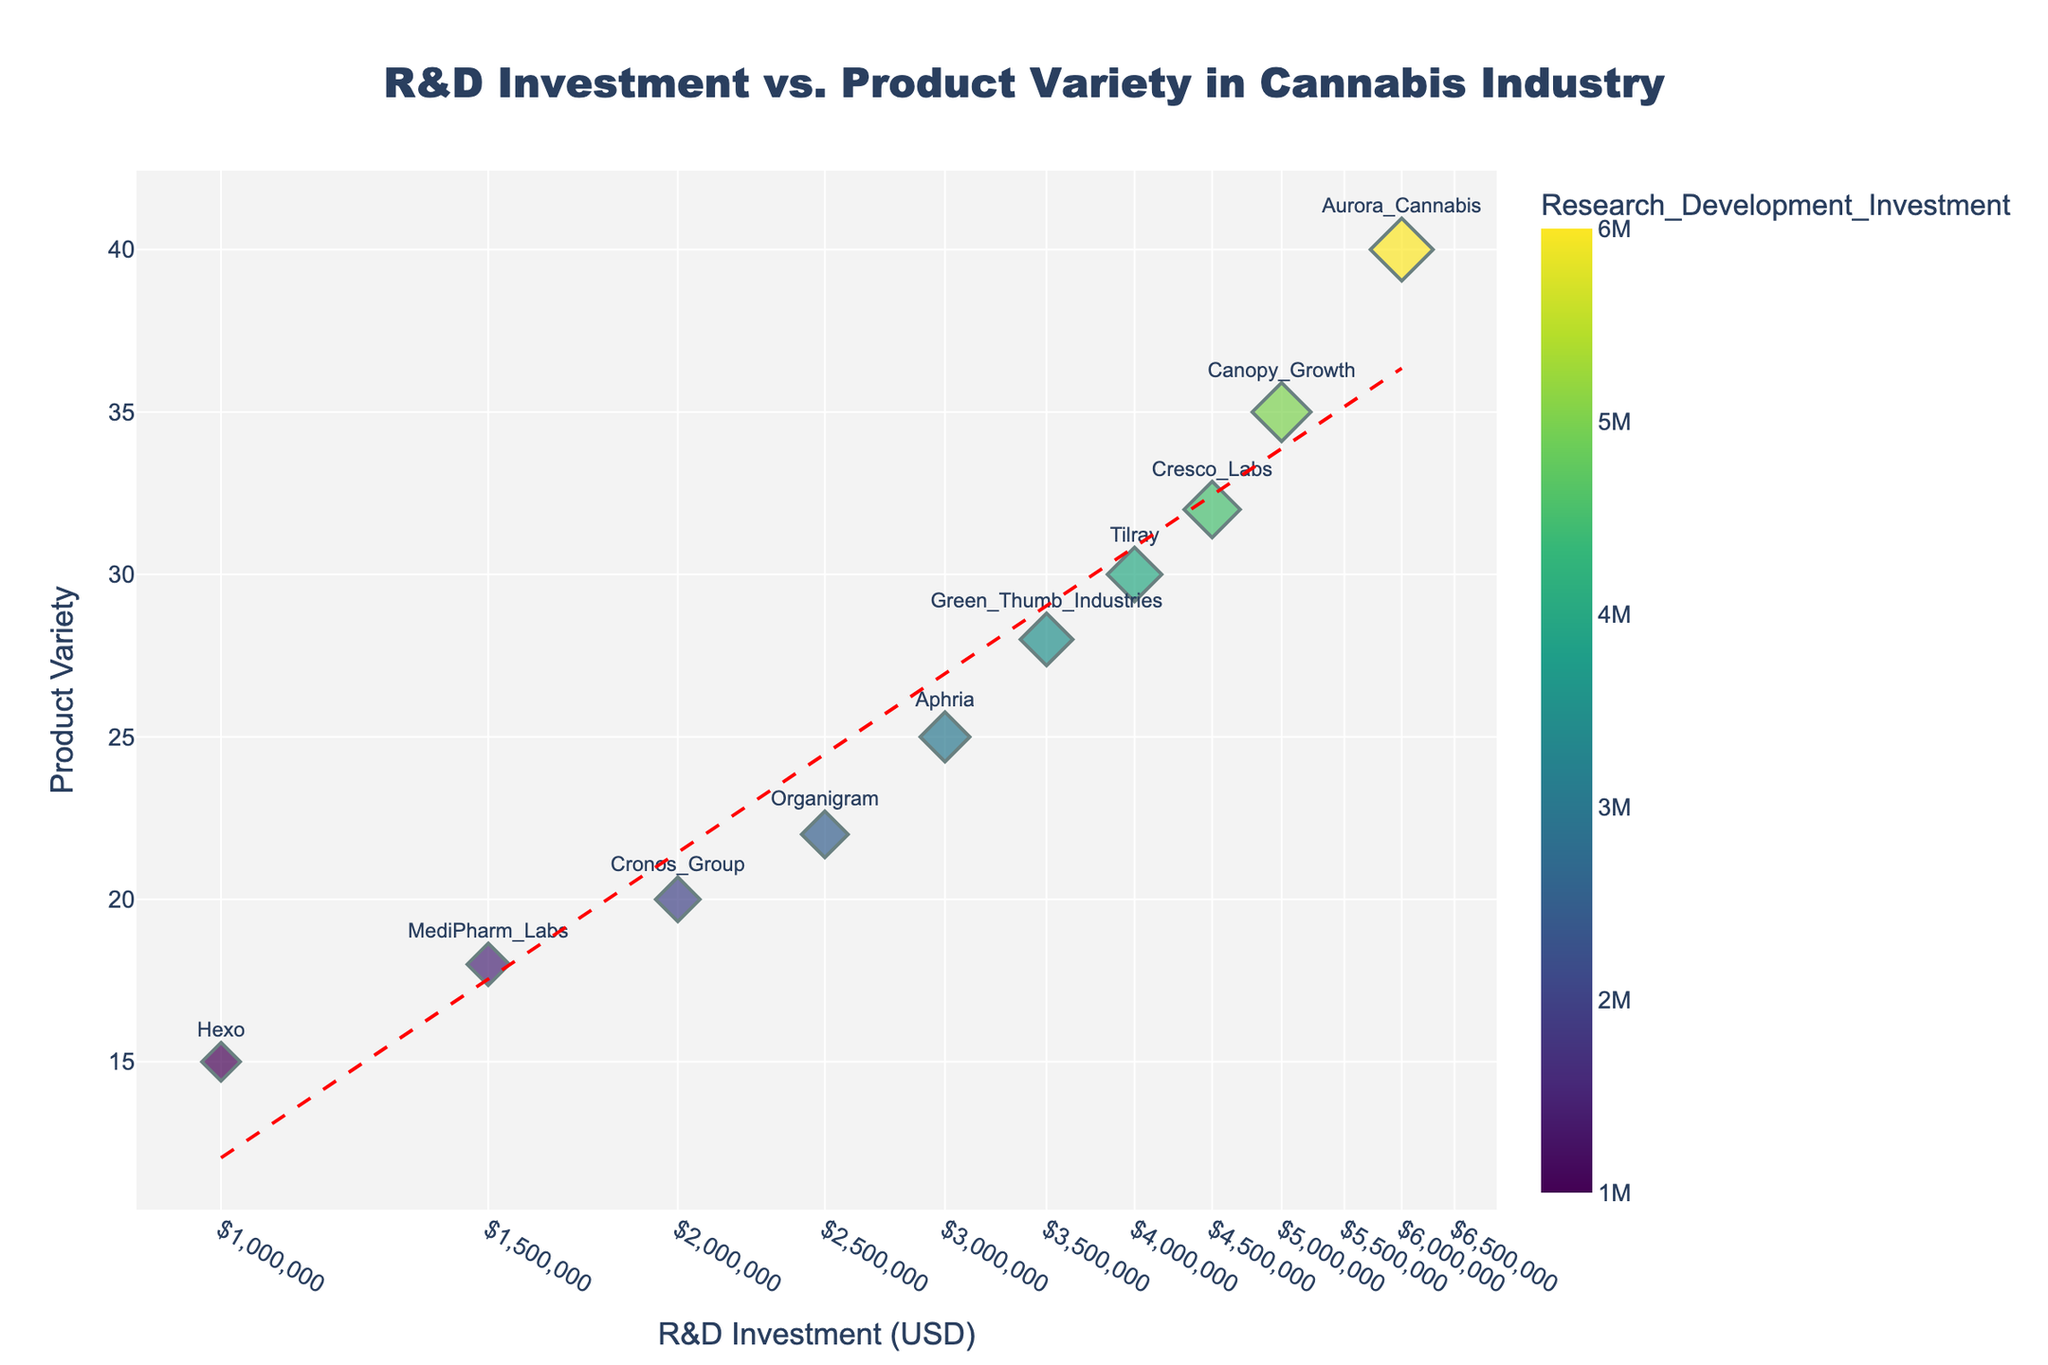What's the title of the scatter plot? The scatter plot's title is clearly displayed at the top and reads "R&D Investment vs. Product Variety in Cannabis Industry."
Answer: R&D Investment vs. Product Variety in Cannabis Industry What does the x-axis represent? By looking at the label on the x-axis, it represents "R&D Investment (USD)."
Answer: R&D Investment (USD) Which company has the highest R&D investment? By observing the data points and referring to the hover information, Aurora Cannabis is located furthest to the right, indicating the highest R&D investment.
Answer: Aurora Cannabis Which company has the lowest product variety? The data point for Hexo, positioned lowest on the y-axis, indicates it has the lowest product variety.
Answer: Hexo Compare the product variety of Aurora Cannabis and Cronos Group. Aurora Cannabis has a product variety of 40, which is higher than the Cronos Group's product variety of 20, as can be observed by looking at their y-axis positions.
Answer: Aurora Cannabis What is the relationship depicted by the trend line? The trend line, which is dashed and red, shows a positive relationship between R&D Investment and Product Variety, meaning as R&D Investment increases, Product Variety tends to increase as well.
Answer: Positive relationship Which company has the most similar product variety to Cresco Labs? By comparing the height of the data points along the y-axis, Green Thumb Industries, with a product variety of 28, is most similar to Cresco Labs' product variety of 32.
Answer: Green Thumb Industries Calculate the average product variety of all companies. To find the average, sum up all the product variety values and divide by the number of companies: (35 + 40 + 25 + 30 + 20 + 15 + 18 + 22 + 32 + 28) / 10 = 26.5.
Answer: 26.5 Find and compare the sum of the R&D investments of Canopy Growth and Tilray. The R&D investments are $5,000,000 for Canopy Growth and $4,000,000 for Tilray. Their sum is $5,000,000 + $4,000,000 = $9,000,000.
Answer: $9,000,000 Is there a company with both above-average R&D investment and product variety? Calculate the averages: mean R&D investment = ($5000000+$6000000+$3000000+$4000000+$2000000+$1000000+$1500000+$2500000+$4500000+$3500000)/10 = $3,200,000 and mean product variety = 26.5. Aurora Cannabis ($6,000,000; 40) and Canopy Growth ($5,000,000; 35) both exceed in both criteria.
Answer: Aurora Cannabis and Canopy Growth 